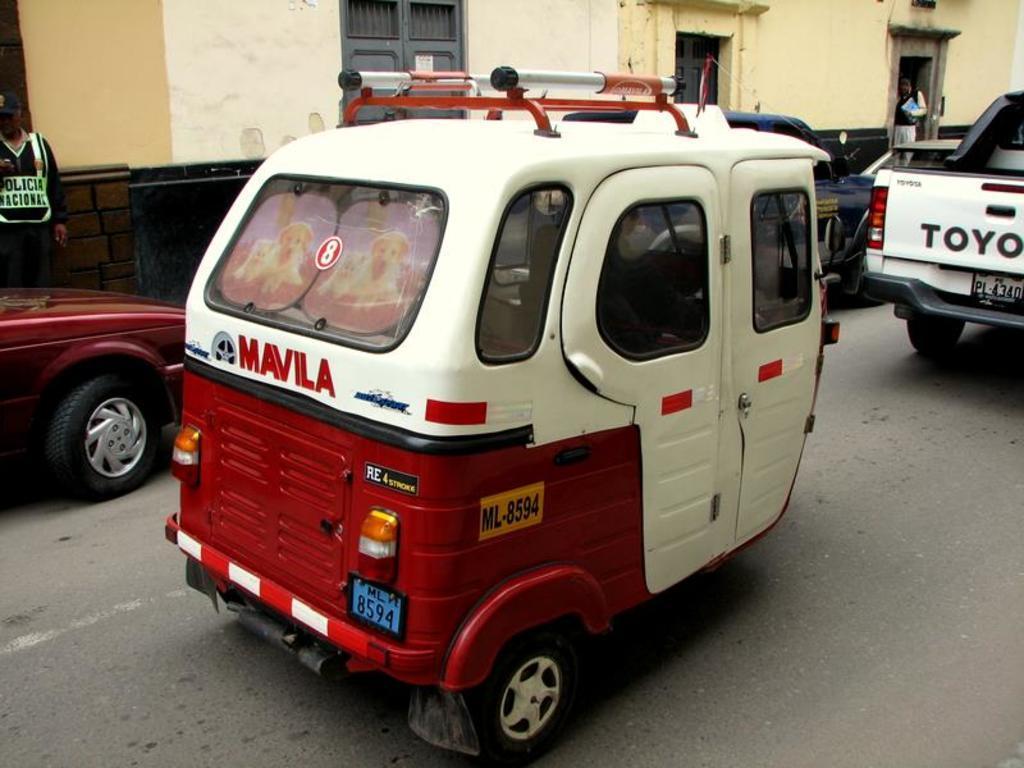In one or two sentences, can you explain what this image depicts? In this image there is white and red color auto riding on the road. In front there is a white van and behind we can see a yellow color house with grey color doors. 